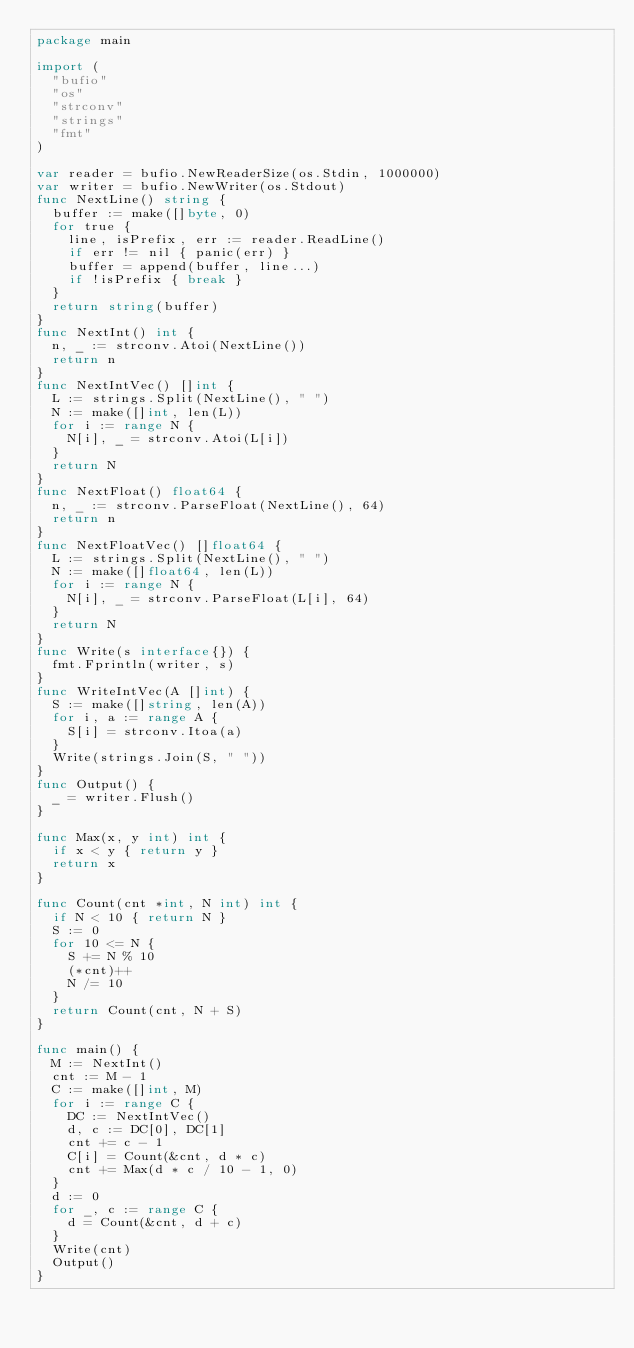<code> <loc_0><loc_0><loc_500><loc_500><_Go_>package main

import (
  "bufio"
  "os"
  "strconv"
  "strings"
  "fmt"
)

var reader = bufio.NewReaderSize(os.Stdin, 1000000)
var writer = bufio.NewWriter(os.Stdout)
func NextLine() string {
  buffer := make([]byte, 0)
  for true {
    line, isPrefix, err := reader.ReadLine()
    if err != nil { panic(err) }
    buffer = append(buffer, line...)
    if !isPrefix { break }
  }
  return string(buffer)
}
func NextInt() int {
  n, _ := strconv.Atoi(NextLine())
  return n
}
func NextIntVec() []int {
  L := strings.Split(NextLine(), " ")
  N := make([]int, len(L))
  for i := range N {
    N[i], _ = strconv.Atoi(L[i])
  }
  return N
}
func NextFloat() float64 {
  n, _ := strconv.ParseFloat(NextLine(), 64)
  return n
}
func NextFloatVec() []float64 {
  L := strings.Split(NextLine(), " ")
  N := make([]float64, len(L))
  for i := range N {
    N[i], _ = strconv.ParseFloat(L[i], 64)
  }
  return N
}
func Write(s interface{}) {
  fmt.Fprintln(writer, s)
}
func WriteIntVec(A []int) {
  S := make([]string, len(A))
  for i, a := range A {
    S[i] = strconv.Itoa(a)
  }
  Write(strings.Join(S, " "))
}
func Output() {
  _ = writer.Flush()
}

func Max(x, y int) int {
  if x < y { return y }
  return x
}

func Count(cnt *int, N int) int {
  if N < 10 { return N }
  S := 0
  for 10 <= N {
    S += N % 10
    (*cnt)++
    N /= 10
  }
  return Count(cnt, N + S)
}

func main() {
  M := NextInt()
  cnt := M - 1
  C := make([]int, M)
  for i := range C {
    DC := NextIntVec()
    d, c := DC[0], DC[1]
    cnt += c - 1
    C[i] = Count(&cnt, d * c)
    cnt += Max(d * c / 10 - 1, 0)
  }
  d := 0
  for _, c := range C {
    d = Count(&cnt, d + c)
  }
  Write(cnt)
  Output()
}</code> 